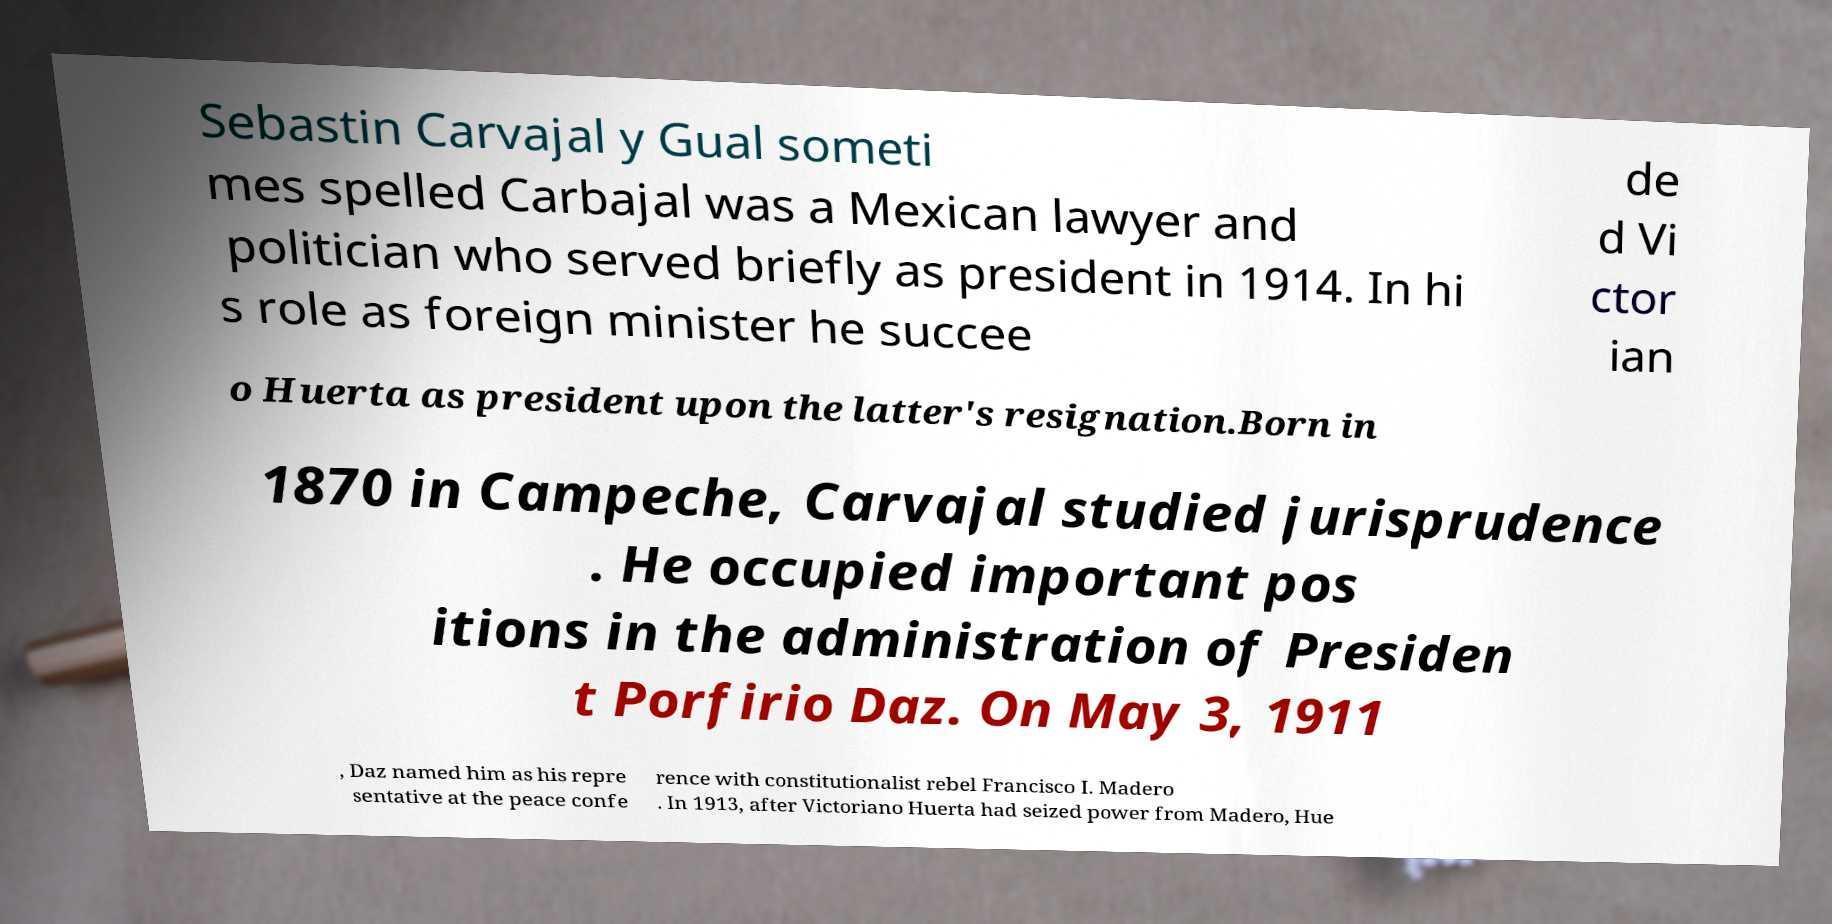For documentation purposes, I need the text within this image transcribed. Could you provide that? Sebastin Carvajal y Gual someti mes spelled Carbajal was a Mexican lawyer and politician who served briefly as president in 1914. In hi s role as foreign minister he succee de d Vi ctor ian o Huerta as president upon the latter's resignation.Born in 1870 in Campeche, Carvajal studied jurisprudence . He occupied important pos itions in the administration of Presiden t Porfirio Daz. On May 3, 1911 , Daz named him as his repre sentative at the peace confe rence with constitutionalist rebel Francisco I. Madero . In 1913, after Victoriano Huerta had seized power from Madero, Hue 